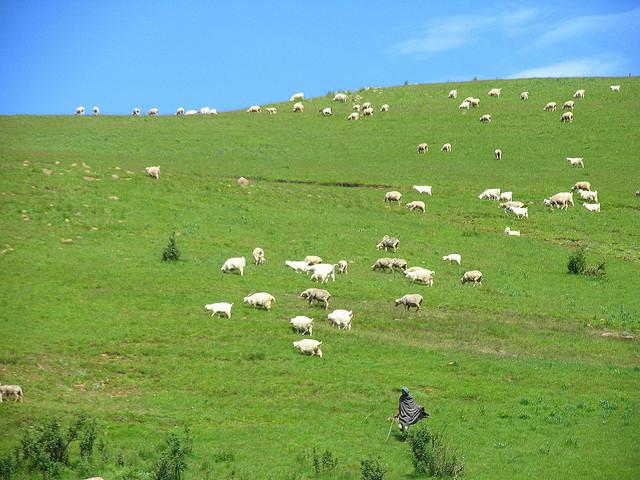Is there a person?
Write a very short answer. No. In total how many sheep are visible in this photo?
Answer briefly. 50. Can you see a wolf stalking the sheep?
Quick response, please. No. 